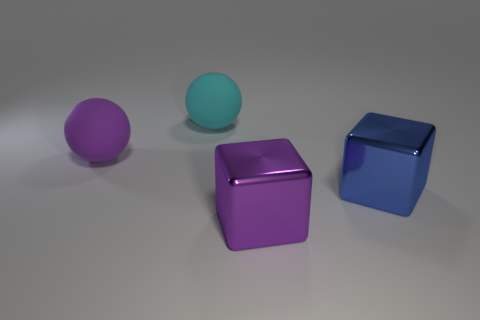Do the blue metal block and the shiny thing to the left of the large blue shiny object have the same size?
Offer a terse response. Yes. There is a block on the right side of the purple metal cube in front of the cyan matte sphere; is there a large matte object that is in front of it?
Ensure brevity in your answer.  No. What is the material of the purple thing that is to the right of the purple thing that is behind the big purple shiny cube?
Provide a short and direct response. Metal. What is the material of the thing that is behind the big purple metal block and right of the big cyan object?
Your response must be concise. Metal. Is there a big purple matte thing that has the same shape as the cyan rubber object?
Your answer should be very brief. Yes. Are there any blue shiny objects that are on the left side of the thing on the left side of the cyan matte thing?
Your answer should be compact. No. What number of gray things are the same material as the blue block?
Your response must be concise. 0. Are any big metallic objects visible?
Offer a very short reply. Yes. Do the blue block and the sphere that is behind the purple matte sphere have the same material?
Your answer should be very brief. No. Is the number of large blue shiny blocks that are in front of the cyan ball greater than the number of gray cylinders?
Your answer should be compact. Yes. 